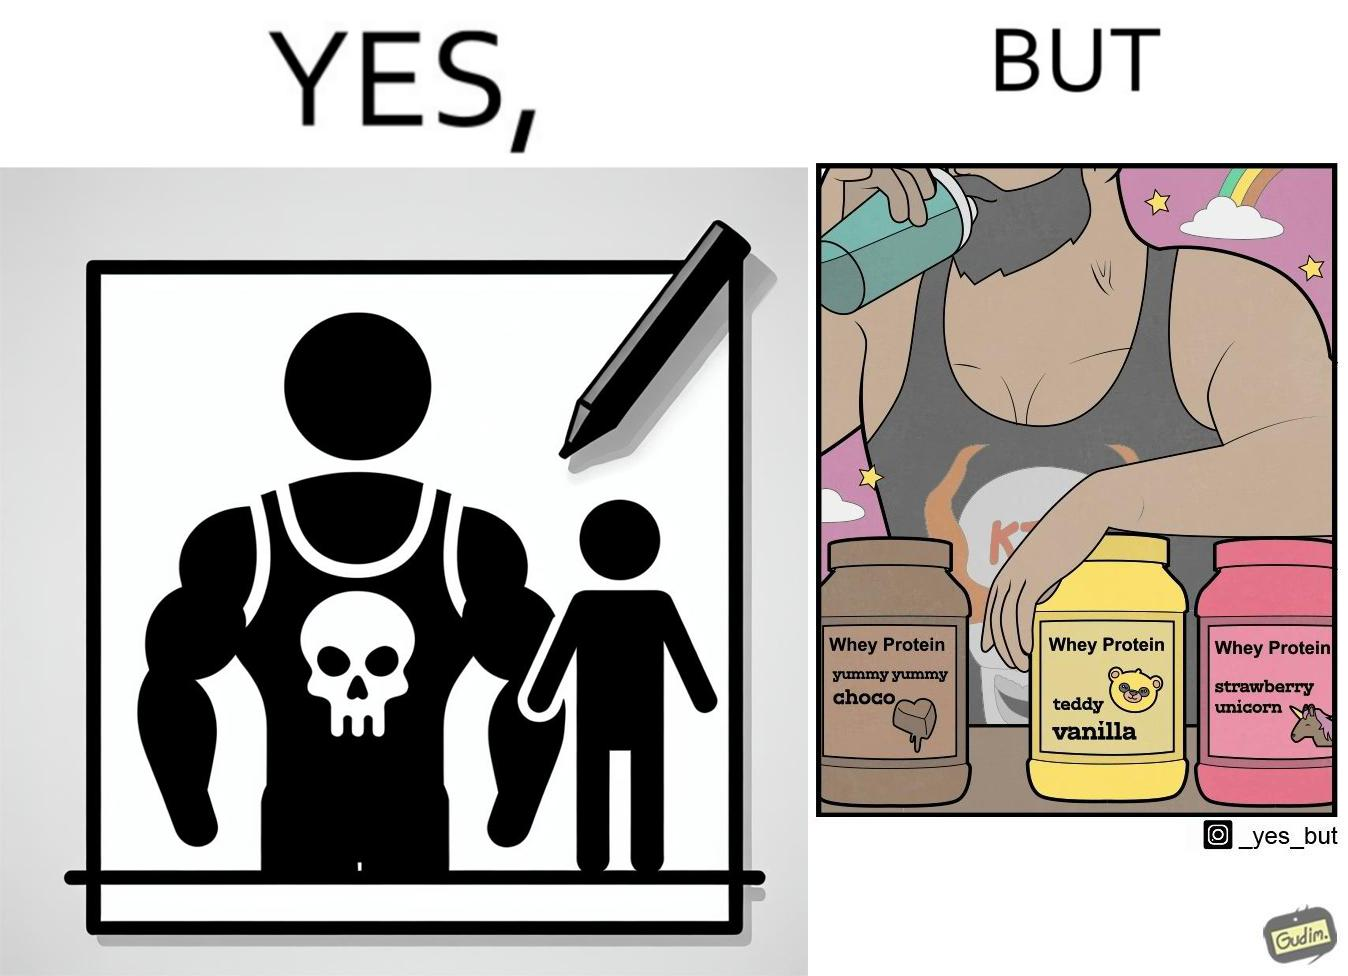Provide a description of this image. The image is funny because a well-built person wearing an aggressive tank-top with the word "KILL" on an image of a skull is having very childish flavours of whey protein such as teddy vanilla, yummy yummy choco, and strawberry vanilla, contrary to the person's external persona. This depicts the metaphor 'Do not judge a book by its cover'. 